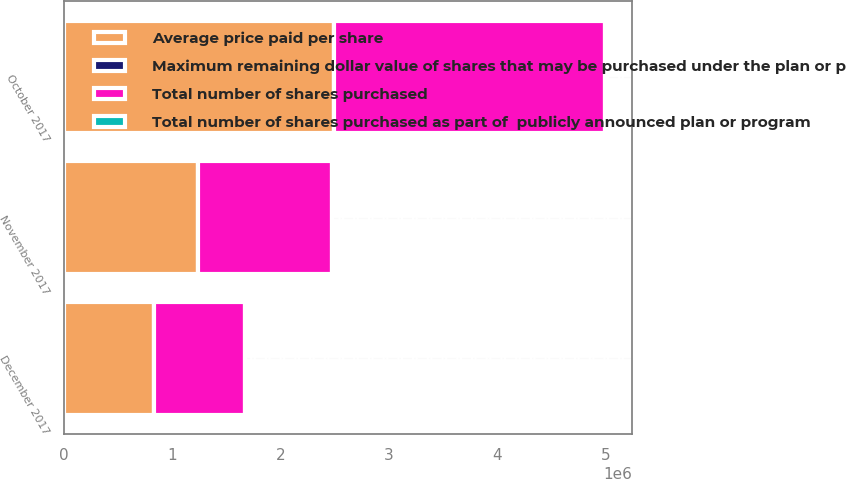Convert chart to OTSL. <chart><loc_0><loc_0><loc_500><loc_500><stacked_bar_chart><ecel><fcel>October 2017<fcel>November 2017<fcel>December 2017<nl><fcel>Average price paid per share<fcel>2.49746e+06<fcel>1.23655e+06<fcel>834577<nl><fcel>Total number of shares purchased as part of  publicly announced plan or program<fcel>50.37<fcel>47.59<fcel>50.96<nl><fcel>Total number of shares purchased<fcel>2.49746e+06<fcel>1.23655e+06<fcel>834577<nl><fcel>Maximum remaining dollar value of shares that may be purchased under the plan or program in millions<fcel>551<fcel>492<fcel>450<nl></chart> 